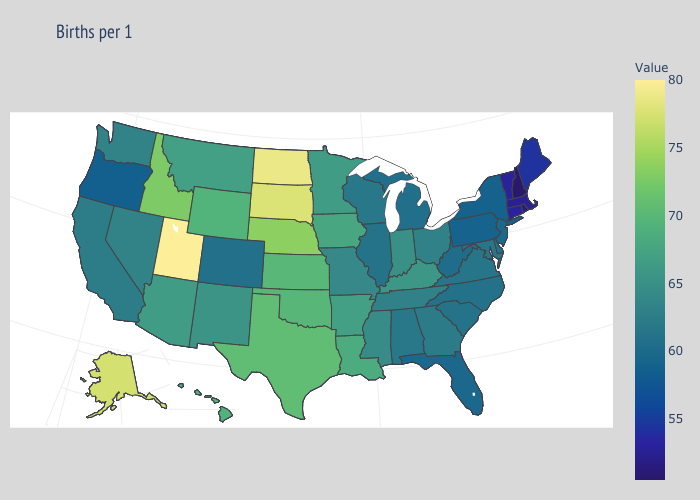Does Oklahoma have a lower value than Pennsylvania?
Concise answer only. No. Does Mississippi have a lower value than Iowa?
Be succinct. Yes. Does New Hampshire have the lowest value in the USA?
Keep it brief. Yes. Among the states that border Louisiana , which have the lowest value?
Give a very brief answer. Mississippi. Does Delaware have a lower value than Mississippi?
Be succinct. Yes. Does North Dakota have the highest value in the MidWest?
Keep it brief. Yes. 